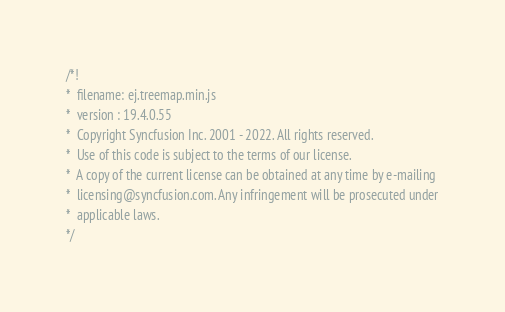<code> <loc_0><loc_0><loc_500><loc_500><_JavaScript_>/*!
*  filename: ej.treemap.min.js
*  version : 19.4.0.55
*  Copyright Syncfusion Inc. 2001 - 2022. All rights reserved.
*  Use of this code is subject to the terms of our license.
*  A copy of the current license can be obtained at any time by e-mailing
*  licensing@syncfusion.com. Any infringement will be prosecuted under
*  applicable laws. 
*/</code> 